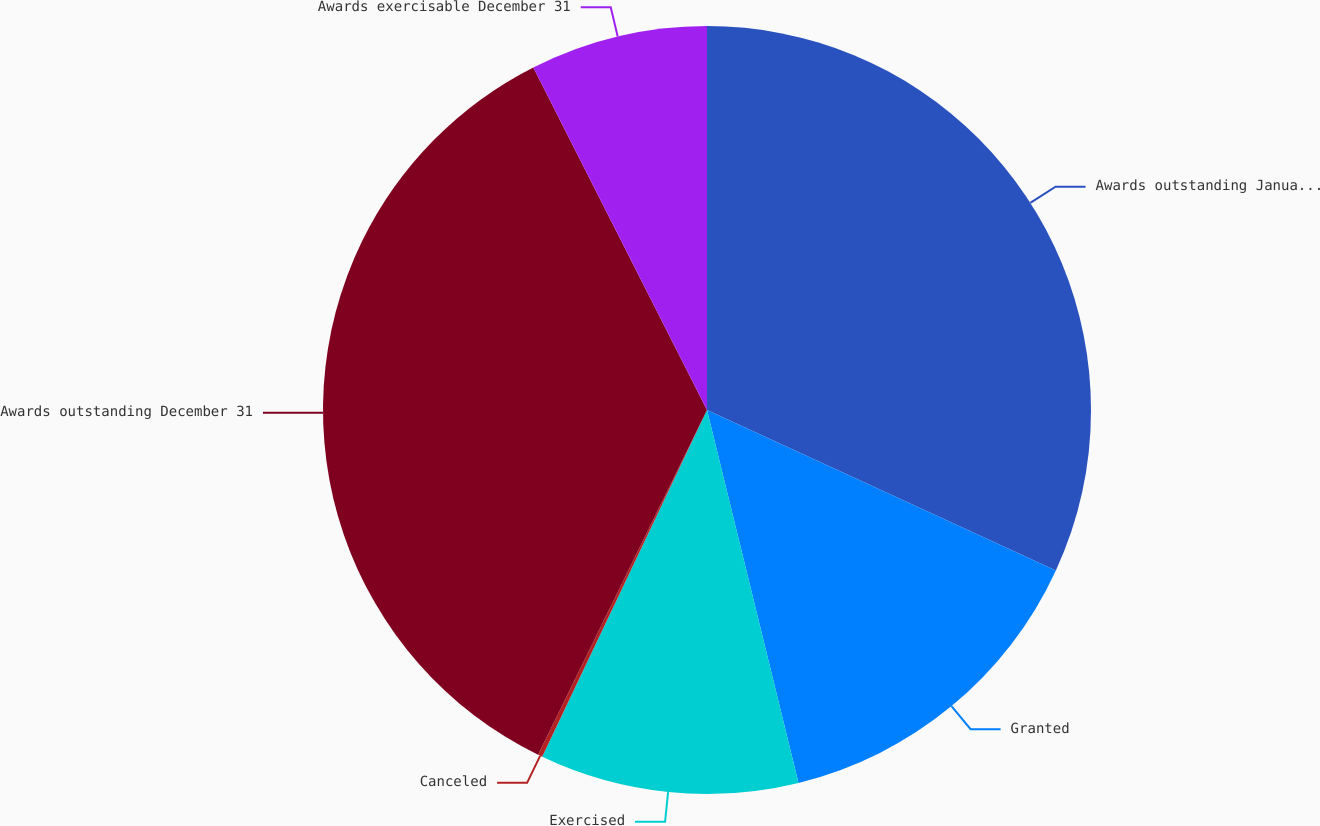Convert chart. <chart><loc_0><loc_0><loc_500><loc_500><pie_chart><fcel>Awards outstanding January 1<fcel>Granted<fcel>Exercised<fcel>Canceled<fcel>Awards outstanding December 31<fcel>Awards exercisable December 31<nl><fcel>31.86%<fcel>14.31%<fcel>10.89%<fcel>0.19%<fcel>35.28%<fcel>7.47%<nl></chart> 